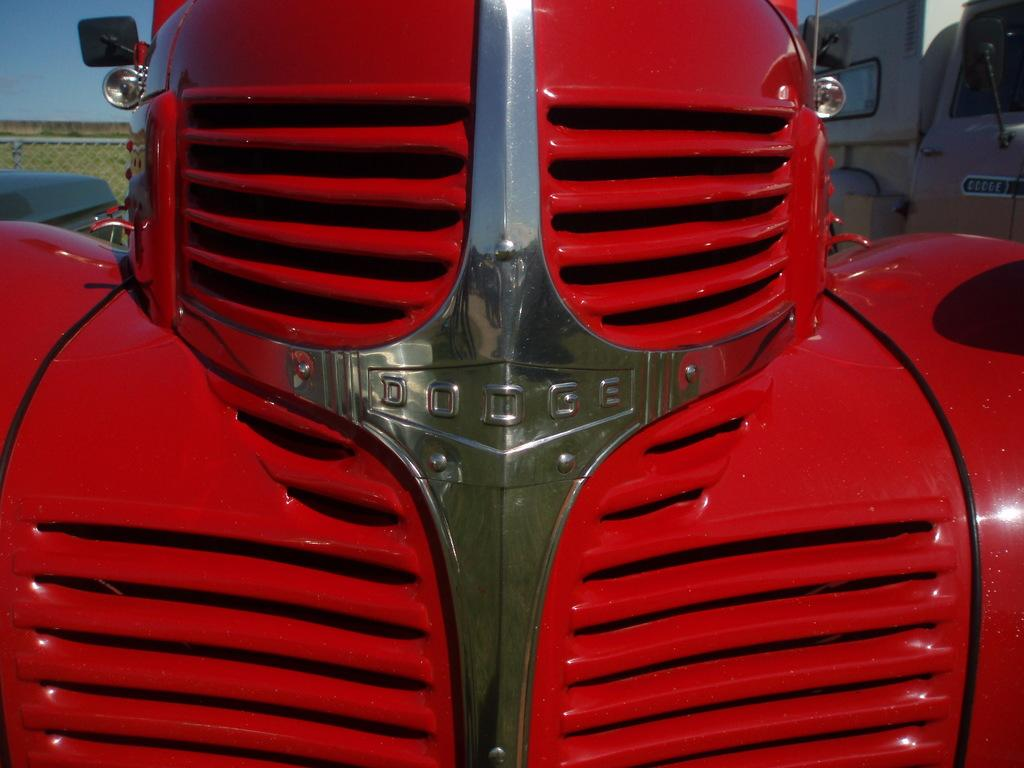What is the main subject in the foreground of the image? There is a tractor in the foreground of the image. What other vehicle can be seen in the image? There is a vehicle on the right side of the image. What is located on the left side of the image? There is fencing and greenery on the left side of the image. What part of the natural environment is visible in the image? The sky is visible in the image. Can you describe the front part of a vehicle in the image? The front part of a vehicle is visible on the left side of the image. What type of polish is being applied to the tractor in the image? There is no indication in the image that any polish is being applied to the tractor. Can you see the coastline in the image? There is no coastline visible in the image; it features a tractor, vehicles, fencing, greenery, and the sky. 